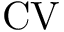<formula> <loc_0><loc_0><loc_500><loc_500>C V</formula> 